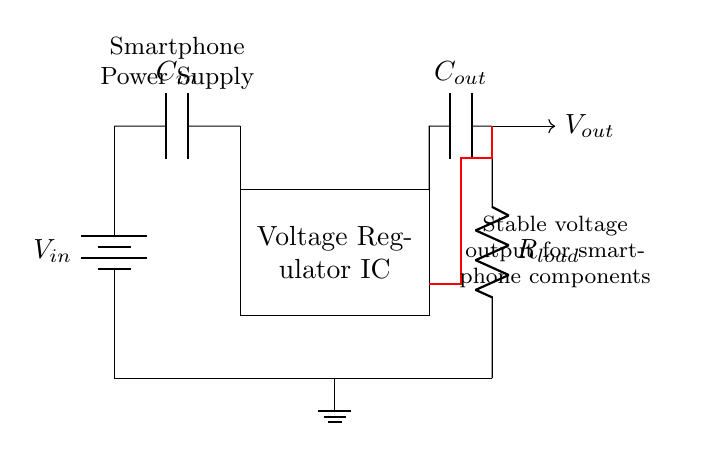What is the input voltage source in this circuit? The circuit diagram indicates a battery labeled as V_in. It provides the input voltage to the voltage regulator.
Answer: V_in What is the role of the capacitor labeled C_out? C_out is connected to the output side of the voltage regulator. Its role is to stabilize the output voltage and filter any noise.
Answer: Stabilization What component maintains a stable output voltage? The voltage regulator IC is responsible for maintaining stable output voltage despite variations in input voltage or load conditions.
Answer: Voltage Regulator IC How many capacitors are present in the circuit? The circuit shows two capacitors: C_in at the input side and C_out at the output side.
Answer: Two What is the function of the resistor labeled R_load? R_load represents the load in the circuit, as it consumes the regulated output voltage. It connects from the output to ground, completing the load circuit.
Answer: Load resistor What is the feedback mechanism in this circuit? The feedback mechanism involves a loop from the output (C_out and R_load) back to the voltage regulator IC. This feedback allows the regulator to adjust its output to maintain a constant voltage.
Answer: Feedback loop What is the significance of the ground connection in this setup? The ground connection establishes a common reference point for the circuit's voltages, aiding in the stability and functionality of the entire circuit.
Answer: Common reference 